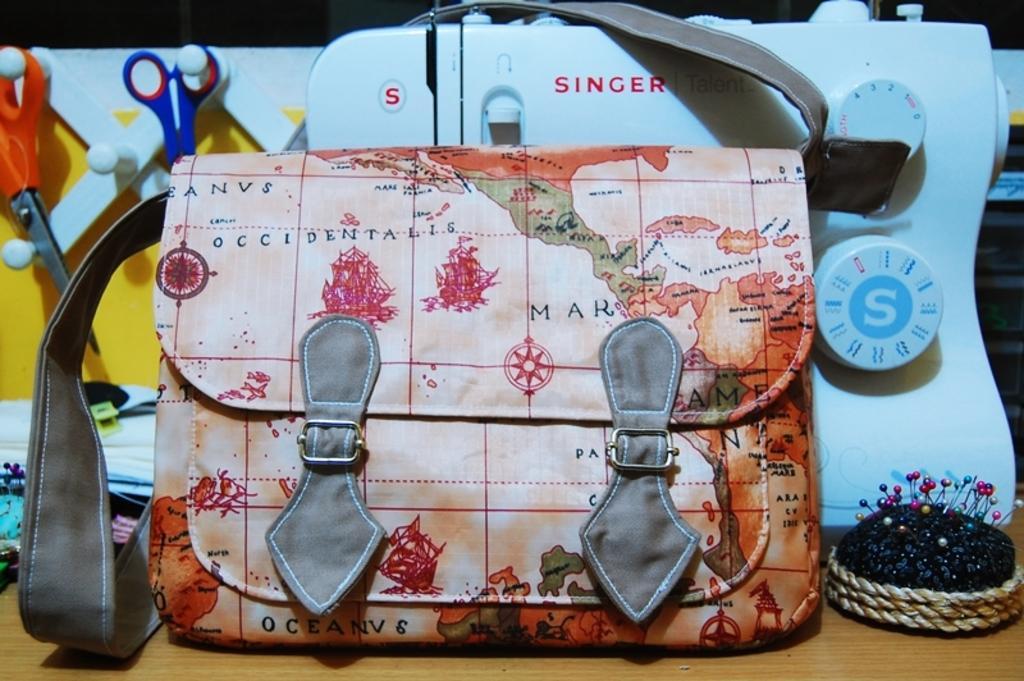In one or two sentences, can you explain what this image depicts? In this image, In the middle there is a bag which is in orange color and in the background there is a white color object and in the left side there are two scissors which are in orange and blue color and in the right side there is a black color object on the table. 